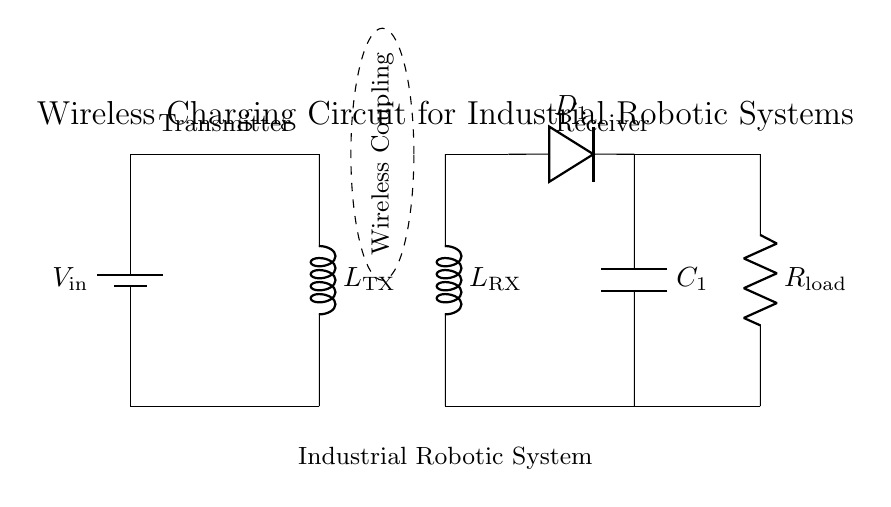What is the input voltage of the transmitter? The input voltage of the transmitter is labeled as V_in at the battery. It's indicated next to the battery component.
Answer: V_in What type of load is connected to the receiver side? The load connected to the receiver side is a resistor labeled R_load, signifying that the circuit is designed to power a resistive load.
Answer: Resistor What is the function of the component D_1 in the circuit? The component D_1 is a diode; its purpose is to allow current to flow in one direction, which is essential for converting the alternating current produced by the inductors into direct current for charging.
Answer: Diode How many inductors are present in the circuit? There are two inductors in the circuit: one on the transmitter side labeled L_TX and the other on the receiver side labeled L_RX. You can see them listed in their respective positions.
Answer: Two What type of circuit is this? This circuit is a wireless charging circuit designed specifically for industrial robotic systems, indicating that it focuses on transferring power without physical connections through electromagnetic fields.
Answer: Wireless charging circuit What does the dashed ellipse represent in the circuit diagram? The dashed ellipse represents the wireless coupling area where the energy transfer occurs between the transmitter and receiver inductors, emphasizing that the energy is transferred without direct electrical connections.
Answer: Wireless Coupling What is the role of capacitor C_1 in this circuit? The role of capacitor C_1 is to smooth out the output voltage coming from the rectified current, which helps to stabilize the voltage supplied to the load connected to the receiver side.
Answer: Smoothing 